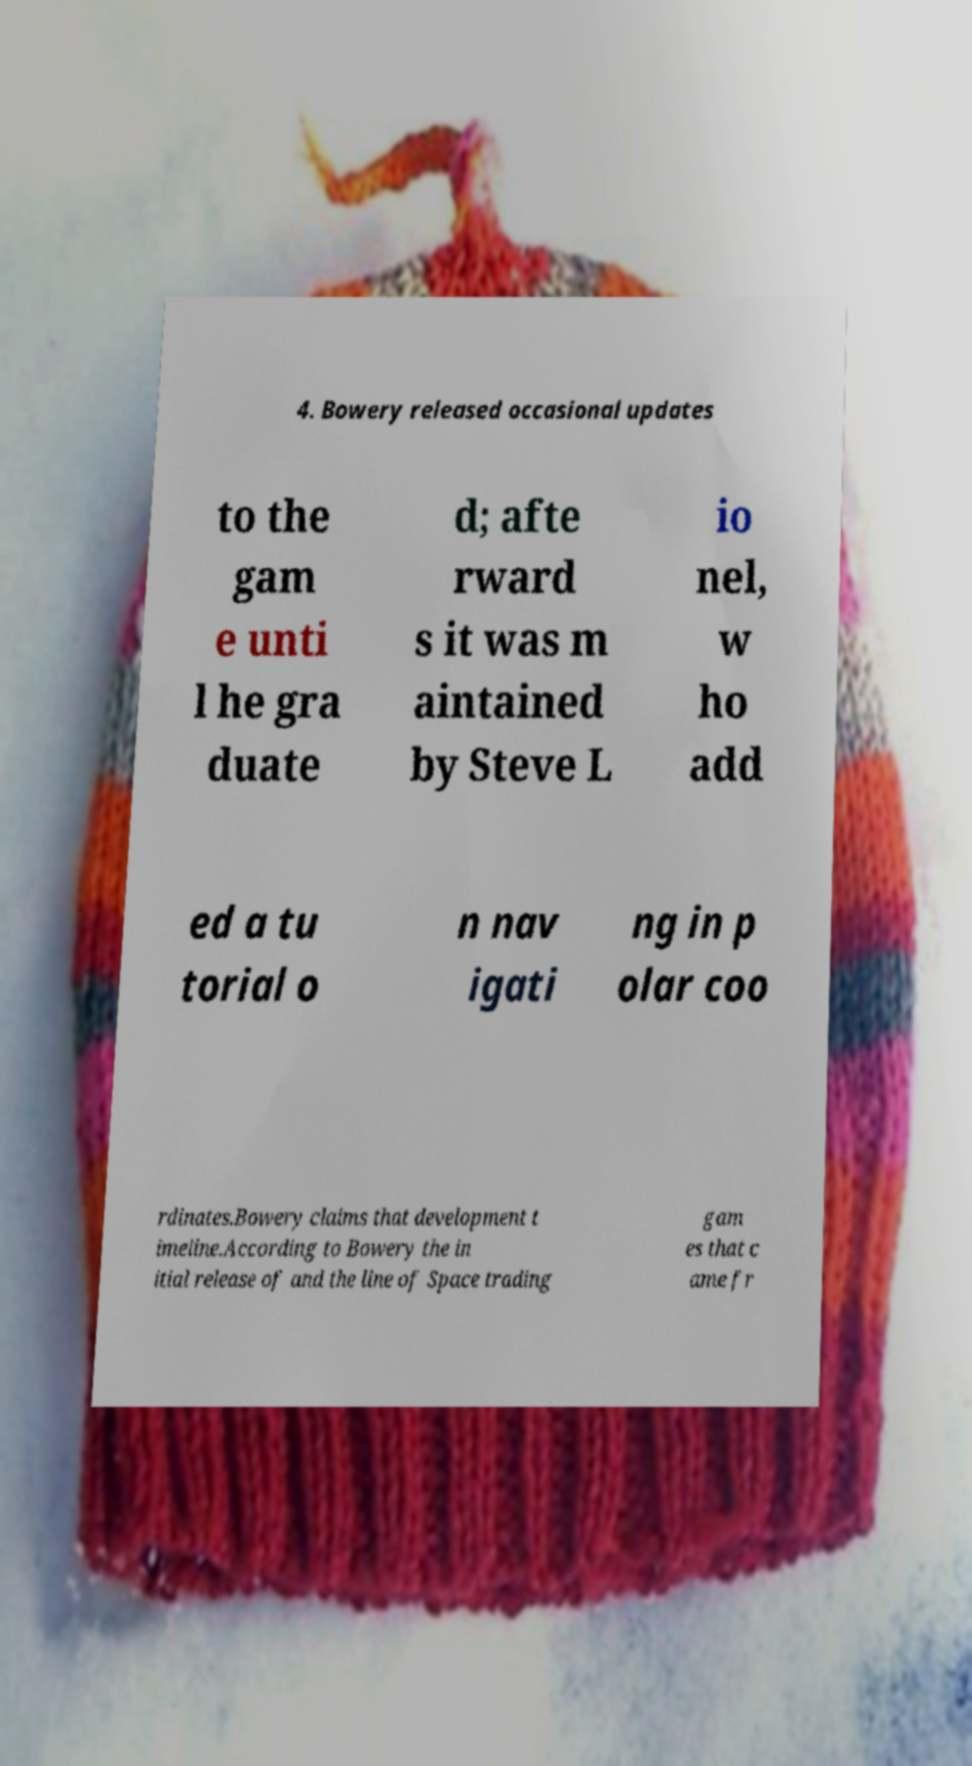There's text embedded in this image that I need extracted. Can you transcribe it verbatim? 4. Bowery released occasional updates to the gam e unti l he gra duate d; afte rward s it was m aintained by Steve L io nel, w ho add ed a tu torial o n nav igati ng in p olar coo rdinates.Bowery claims that development t imeline.According to Bowery the in itial release of and the line of Space trading gam es that c ame fr 